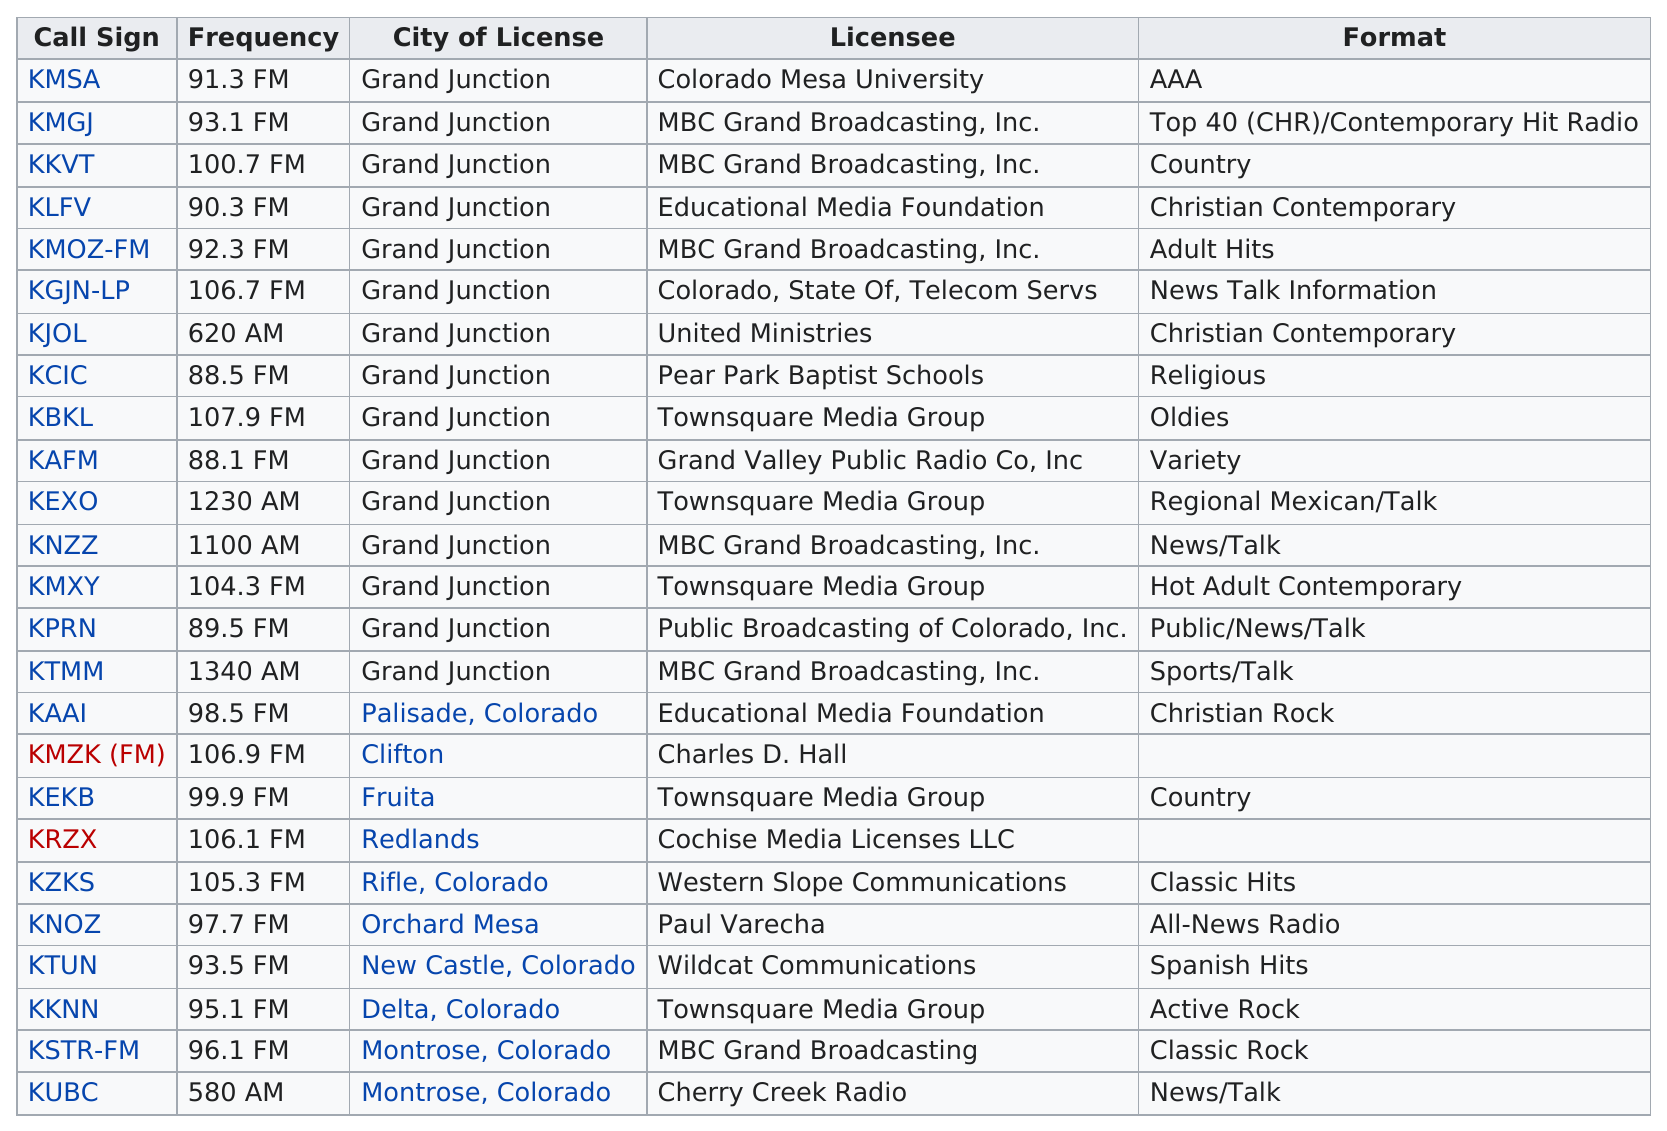Give some essential details in this illustration. There are two Christian contemporary stations. The news/talk format has the most unique frequencies among all station formats. Montrose, Colorado has more call signs than Fruita. I declare that there is only one station that shares the same format as the station KLFV. Grand Junction is one of the cities that have at least three call signs. 